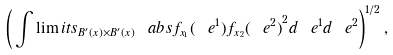<formula> <loc_0><loc_0><loc_500><loc_500>\left ( \, \int \lim i t s _ { B ^ { \prime } ( x ) \times B ^ { \prime } ( x ) } \ a b s { f _ { x _ { 1 } } ( \ e ^ { 1 } ) f _ { x _ { 2 } } ( \ e ^ { 2 } ) } ^ { 2 } d \ e ^ { 1 } d \ e ^ { 2 } \right ) ^ { 1 / 2 } ,</formula> 